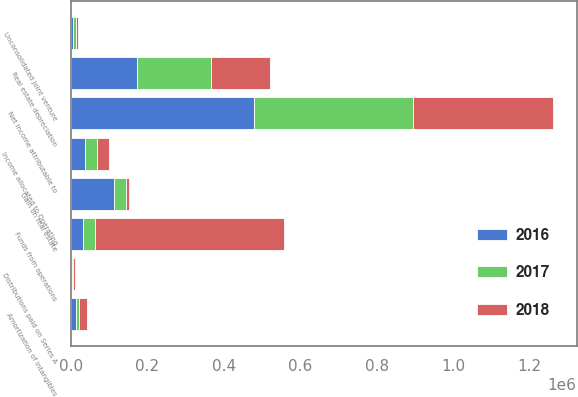Convert chart. <chart><loc_0><loc_0><loc_500><loc_500><stacked_bar_chart><ecel><fcel>Net income attributable to<fcel>Real estate depreciation<fcel>Amortization of intangibles<fcel>Gain on real estate<fcel>Unconsolidated joint venture<fcel>Distributions paid on Series A<fcel>Income allocated to Operating<fcel>Funds from operations<nl><fcel>2017<fcel>415289<fcel>193587<fcel>8340<fcel>30807<fcel>7064<fcel>2288<fcel>31791<fcel>30884.5<nl><fcel>2016<fcel>479013<fcel>172660<fcel>13591<fcel>112789<fcel>5489<fcel>3119<fcel>35306<fcel>30884.5<nl><fcel>2018<fcel>366127<fcel>155358<fcel>20467<fcel>8465<fcel>4505<fcel>5085<fcel>30962<fcel>494670<nl></chart> 